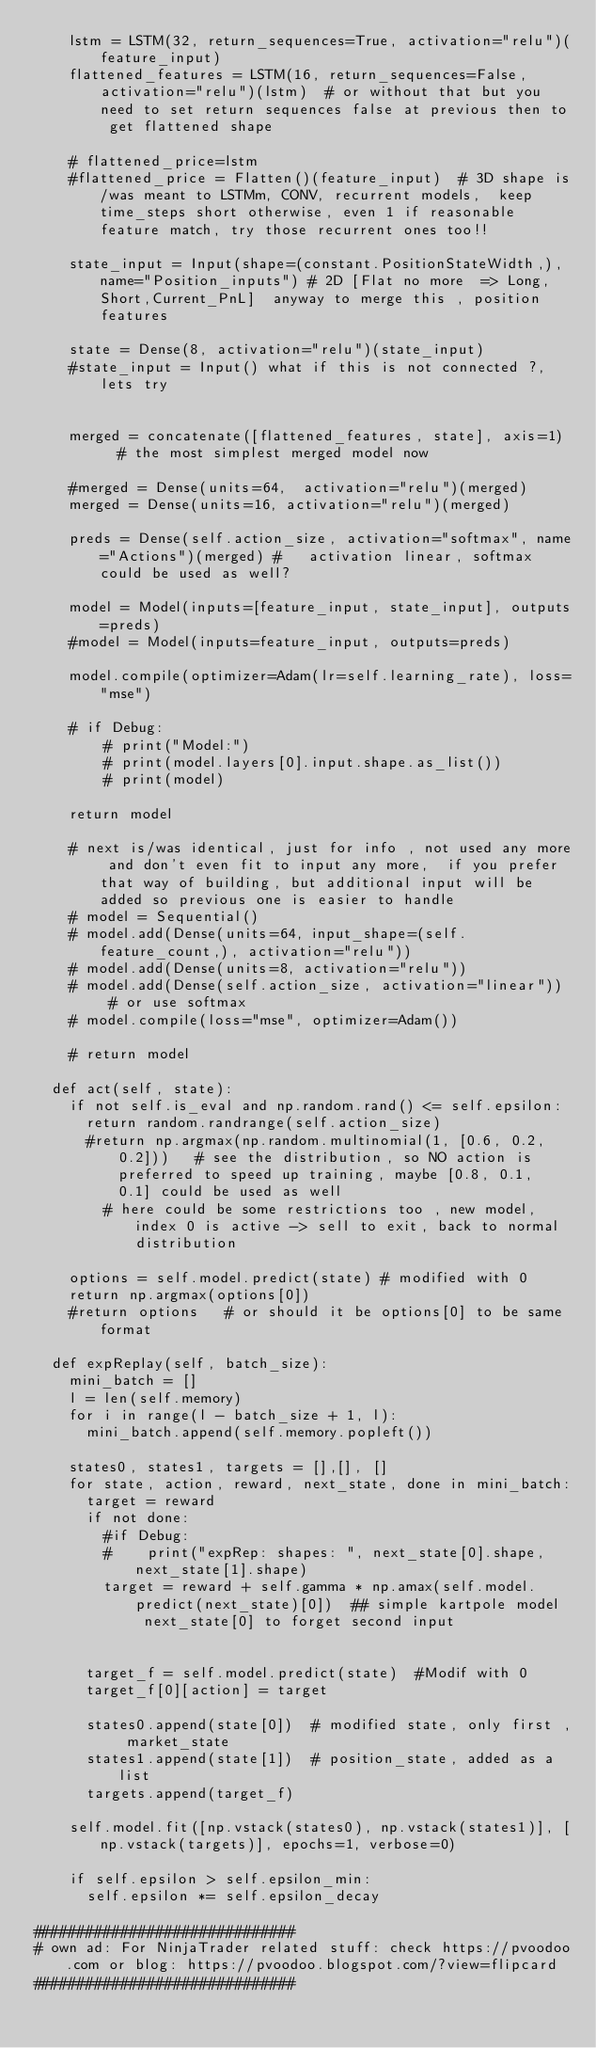Convert code to text. <code><loc_0><loc_0><loc_500><loc_500><_Python_>    lstm = LSTM(32, return_sequences=True, activation="relu")(feature_input)
    flattened_features = LSTM(16, return_sequences=False, activation="relu")(lstm)  # or without that but you need to set return sequences false at previous then to get flattened shape
    
    # flattened_price=lstm
    #flattened_price = Flatten()(feature_input)  # 3D shape is/was meant to LSTMm, CONV, recurrent models,  keep time_steps short otherwise, even 1 if reasonable feature match, try those recurrent ones too!!
    
    state_input = Input(shape=(constant.PositionStateWidth,), name="Position_inputs") # 2D [Flat no more  => Long,Short,Current_PnL]  anyway to merge this , position features
 
    state = Dense(8, activation="relu")(state_input)
    #state_input = Input() what if this is not connected ?, lets try
   
   
    merged = concatenate([flattened_features, state], axis=1)   # the most simplest merged model now 
    
    #merged = Dense(units=64,  activation="relu")(merged)
    merged = Dense(units=16, activation="relu")(merged)
    
    preds = Dense(self.action_size, activation="softmax", name="Actions")(merged) #   activation linear, softmax could be used as well?
    
    model = Model(inputs=[feature_input, state_input], outputs=preds)
    #model = Model(inputs=feature_input, outputs=preds)
    
    model.compile(optimizer=Adam(lr=self.learning_rate), loss="mse")
    
    # if Debug:
        # print("Model:")
        # print(model.layers[0].input.shape.as_list())
        # print(model)
    
    return model
    
    # next is/was identical, just for info , not used any more and don't even fit to input any more,  if you prefer that way of building, but additional input will be added so previous one is easier to handle
    # model = Sequential()
    # model.add(Dense(units=64, input_shape=(self.feature_count,), activation="relu"))
    # model.add(Dense(units=8, activation="relu"))
    # model.add(Dense(self.action_size, activation="linear"))  # or use softmax 
    # model.compile(loss="mse", optimizer=Adam())

    # return model

  def act(self, state):
    if not self.is_eval and np.random.rand() <= self.epsilon:
      return random.randrange(self.action_size)
      #return np.argmax(np.random.multinomial(1, [0.6, 0.2, 0.2]))   # see the distribution, so NO action is preferred to speed up training, maybe [0.8, 0.1, 0.1] could be used as well
        # here could be some restrictions too , new model, index 0 is active -> sell to exit, back to normal distribution
      
    options = self.model.predict(state) # modified with 0
    return np.argmax(options[0])
    #return options   # or should it be options[0] to be same format

  def expReplay(self, batch_size):
    mini_batch = []
    l = len(self.memory)
    for i in range(l - batch_size + 1, l):
      mini_batch.append(self.memory.popleft())

    states0, states1, targets = [],[], []
    for state, action, reward, next_state, done in mini_batch:
      target = reward
      if not done:
        #if Debug:
        #    print("expRep: shapes: ", next_state[0].shape, next_state[1].shape)
        target = reward + self.gamma * np.amax(self.model.predict(next_state)[0])  ## simple kartpole model  next_state[0] to forget second input
        

      target_f = self.model.predict(state)  #Modif with 0
      target_f[0][action] = target

      states0.append(state[0])  # modified state, only first , market_state
      states1.append(state[1])  # position_state, added as a list 
      targets.append(target_f)

    self.model.fit([np.vstack(states0), np.vstack(states1)], [np.vstack(targets)], epochs=1, verbose=0)

    if self.epsilon > self.epsilon_min:
      self.epsilon *= self.epsilon_decay

##############################
# own ad: For NinjaTrader related stuff: check https://pvoodoo.com or blog: https://pvoodoo.blogspot.com/?view=flipcard
##############################
</code> 